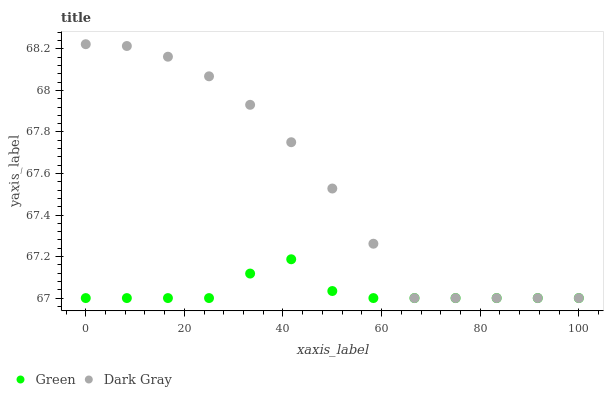Does Green have the minimum area under the curve?
Answer yes or no. Yes. Does Dark Gray have the maximum area under the curve?
Answer yes or no. Yes. Does Green have the maximum area under the curve?
Answer yes or no. No. Is Dark Gray the smoothest?
Answer yes or no. Yes. Is Green the roughest?
Answer yes or no. Yes. Is Green the smoothest?
Answer yes or no. No. Does Dark Gray have the lowest value?
Answer yes or no. Yes. Does Dark Gray have the highest value?
Answer yes or no. Yes. Does Green have the highest value?
Answer yes or no. No. Does Dark Gray intersect Green?
Answer yes or no. Yes. Is Dark Gray less than Green?
Answer yes or no. No. Is Dark Gray greater than Green?
Answer yes or no. No. 